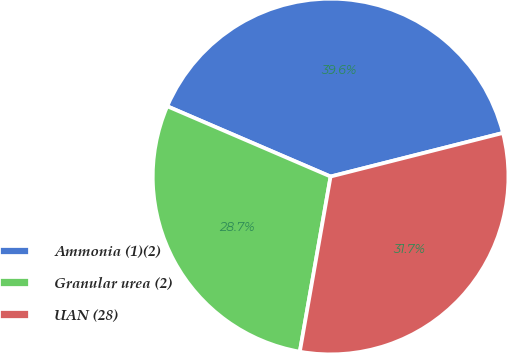Convert chart to OTSL. <chart><loc_0><loc_0><loc_500><loc_500><pie_chart><fcel>Ammonia (1)(2)<fcel>Granular urea (2)<fcel>UAN (28)<nl><fcel>39.59%<fcel>28.7%<fcel>31.71%<nl></chart> 